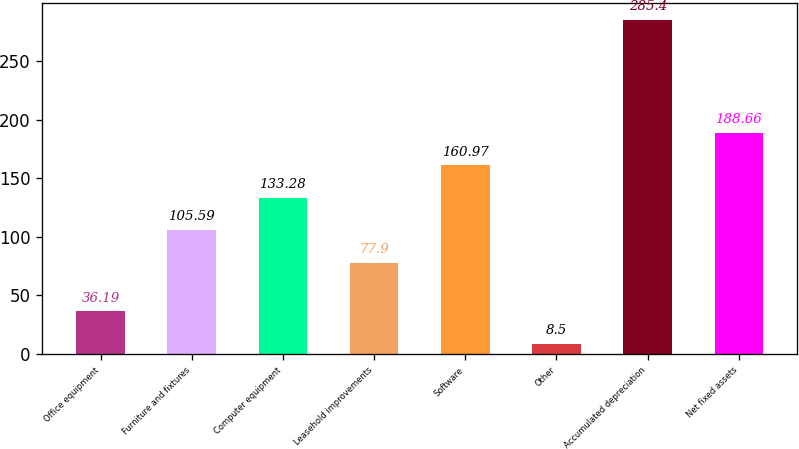Convert chart. <chart><loc_0><loc_0><loc_500><loc_500><bar_chart><fcel>Office equipment<fcel>Furniture and fixtures<fcel>Computer equipment<fcel>Leasehold improvements<fcel>Software<fcel>Other<fcel>Accumulated depreciation<fcel>Net fixed assets<nl><fcel>36.19<fcel>105.59<fcel>133.28<fcel>77.9<fcel>160.97<fcel>8.5<fcel>285.4<fcel>188.66<nl></chart> 